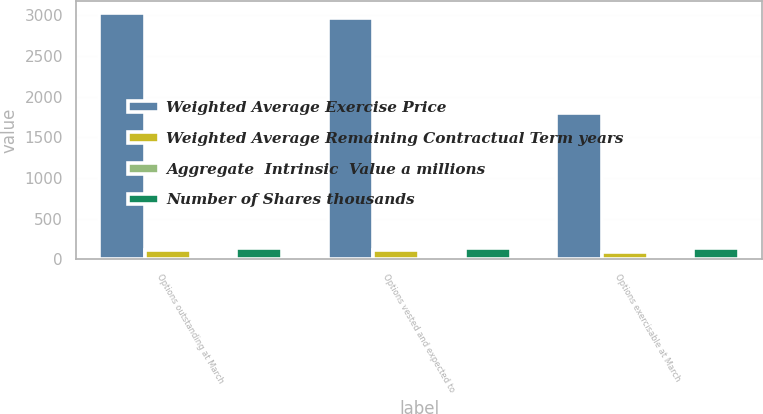<chart> <loc_0><loc_0><loc_500><loc_500><stacked_bar_chart><ecel><fcel>Options outstanding at March<fcel>Options vested and expected to<fcel>Options exercisable at March<nl><fcel>Weighted Average Exercise Price<fcel>3026<fcel>2965<fcel>1804<nl><fcel>Weighted Average Remaining Contractual Term years<fcel>116.66<fcel>115.49<fcel>85.06<nl><fcel>Aggregate  Intrinsic  Value a millions<fcel>4.1<fcel>4.1<fcel>3<nl><fcel>Number of Shares thousands<fcel>143<fcel>143<fcel>134<nl></chart> 